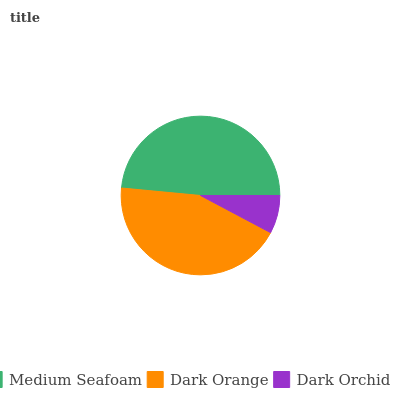Is Dark Orchid the minimum?
Answer yes or no. Yes. Is Medium Seafoam the maximum?
Answer yes or no. Yes. Is Dark Orange the minimum?
Answer yes or no. No. Is Dark Orange the maximum?
Answer yes or no. No. Is Medium Seafoam greater than Dark Orange?
Answer yes or no. Yes. Is Dark Orange less than Medium Seafoam?
Answer yes or no. Yes. Is Dark Orange greater than Medium Seafoam?
Answer yes or no. No. Is Medium Seafoam less than Dark Orange?
Answer yes or no. No. Is Dark Orange the high median?
Answer yes or no. Yes. Is Dark Orange the low median?
Answer yes or no. Yes. Is Dark Orchid the high median?
Answer yes or no. No. Is Dark Orchid the low median?
Answer yes or no. No. 